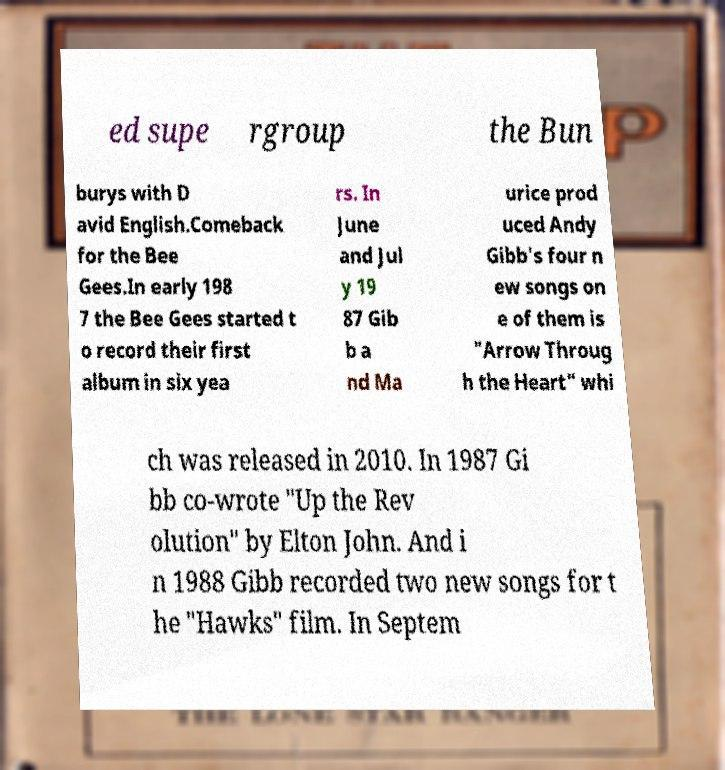Please identify and transcribe the text found in this image. ed supe rgroup the Bun burys with D avid English.Comeback for the Bee Gees.In early 198 7 the Bee Gees started t o record their first album in six yea rs. In June and Jul y 19 87 Gib b a nd Ma urice prod uced Andy Gibb's four n ew songs on e of them is "Arrow Throug h the Heart" whi ch was released in 2010. In 1987 Gi bb co-wrote "Up the Rev olution" by Elton John. And i n 1988 Gibb recorded two new songs for t he "Hawks" film. In Septem 